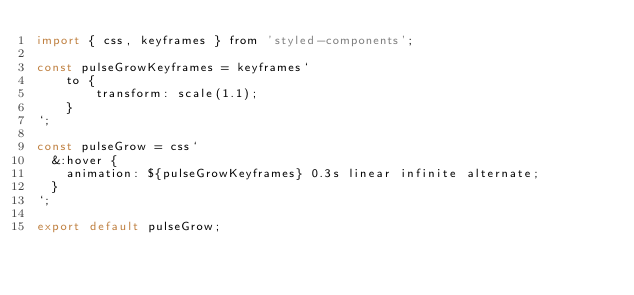Convert code to text. <code><loc_0><loc_0><loc_500><loc_500><_JavaScript_>import { css, keyframes } from 'styled-components';

const pulseGrowKeyframes = keyframes`
    to {
        transform: scale(1.1);
    }
`;

const pulseGrow = css`
  &:hover {
    animation: ${pulseGrowKeyframes} 0.3s linear infinite alternate;
  }
`;

export default pulseGrow;
</code> 